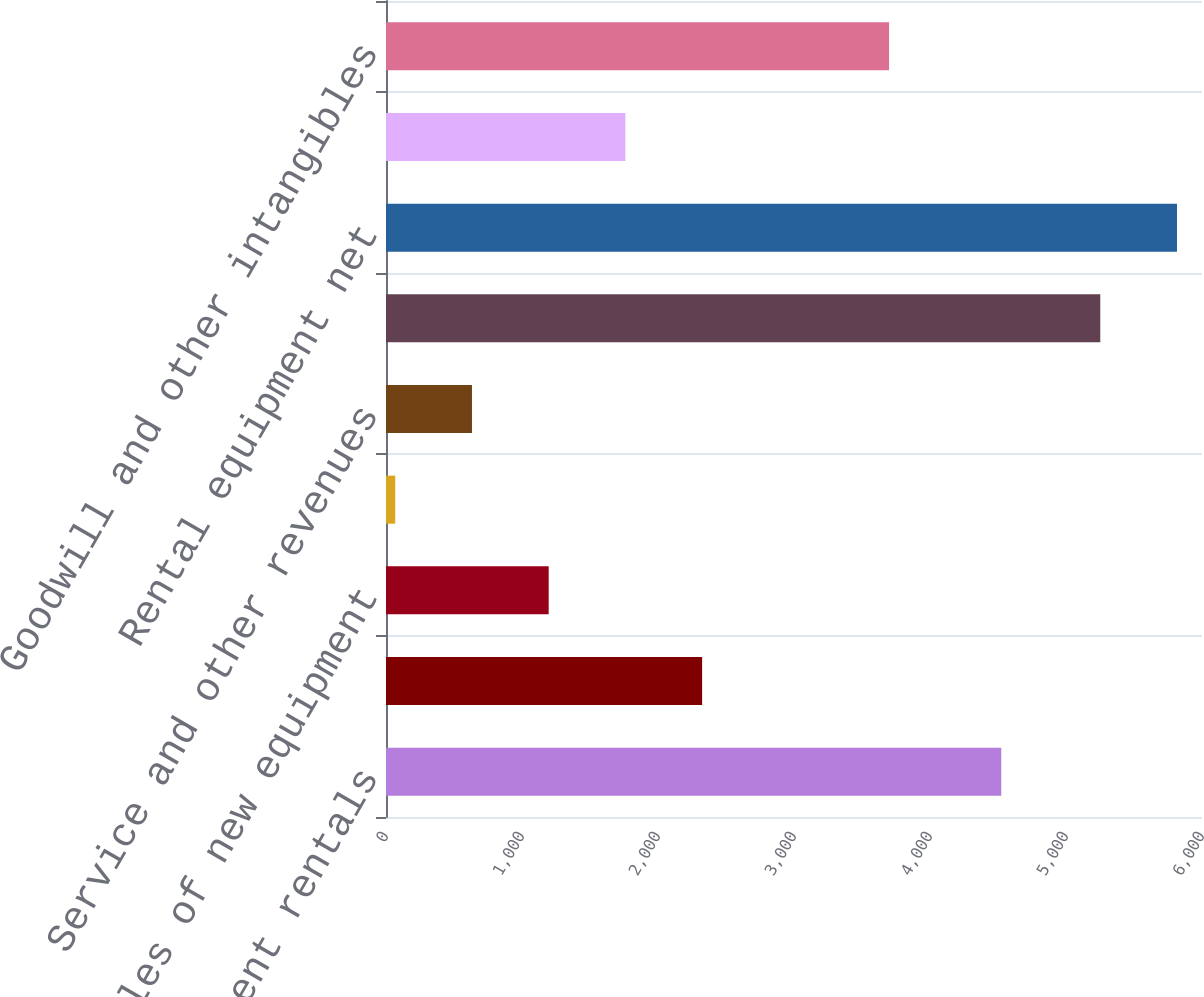Convert chart. <chart><loc_0><loc_0><loc_500><loc_500><bar_chart><fcel>Equipment rentals<fcel>Sales of rental equipment<fcel>Sales of new equipment<fcel>Contractor supplies sales<fcel>Service and other revenues<fcel>Total revenue<fcel>Rental equipment net<fcel>Property and equipment net<fcel>Goodwill and other intangibles<nl><fcel>4524<fcel>2324.4<fcel>1196.2<fcel>68<fcel>632.1<fcel>5252<fcel>5816.1<fcel>1760.3<fcel>3699<nl></chart> 